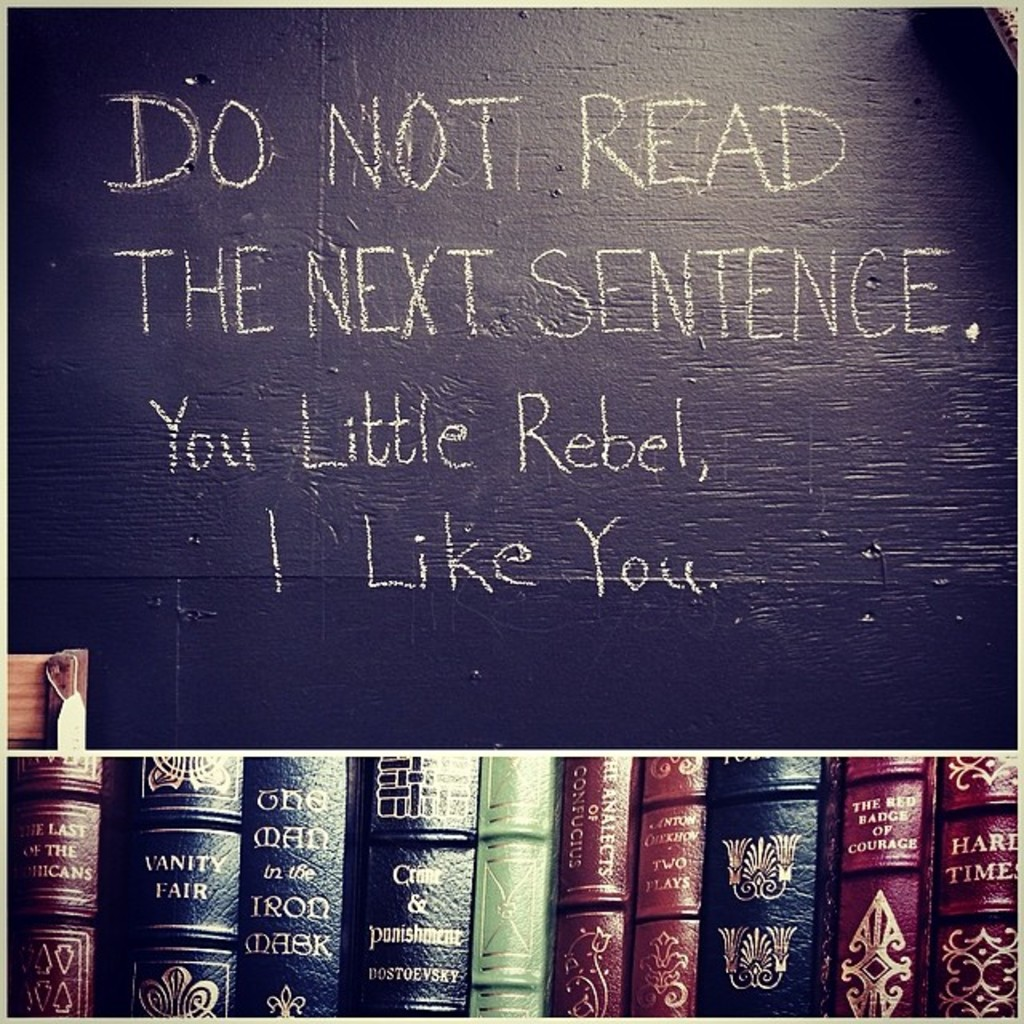Can you tell me more about the themes or messages conveyed through the choice of books below the chalkboard? Certainly! The selection of books under the chalkboard, with titles like 'Vanity Fair' and 'The Count of Monte Cristo,' leans towards classic literature known for exploring themes of socioeconomic struggles, morality, justice, and revenge. Since these books often delve into human emotions and ethical dilemmas, their presence might suggest that the setting encourages reflection on these complex themes, possibly in an educational context where both humor and deep thinking are valued. 